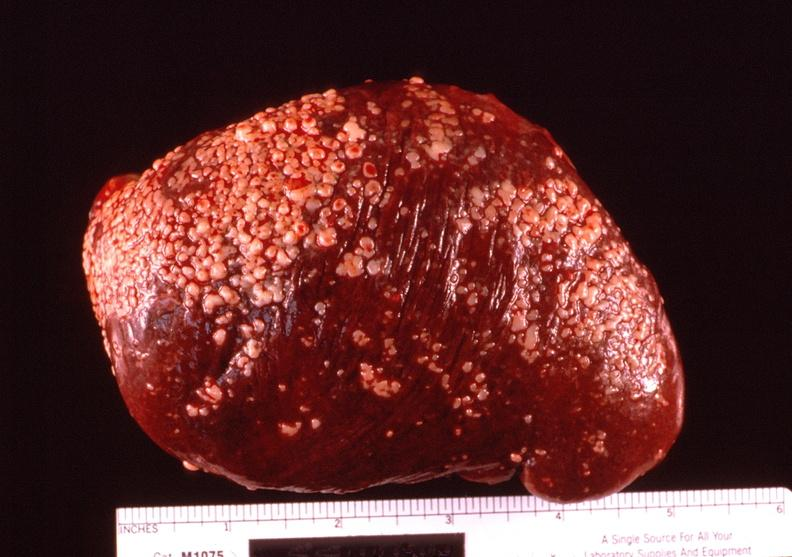s hematologic present?
Answer the question using a single word or phrase. Yes 